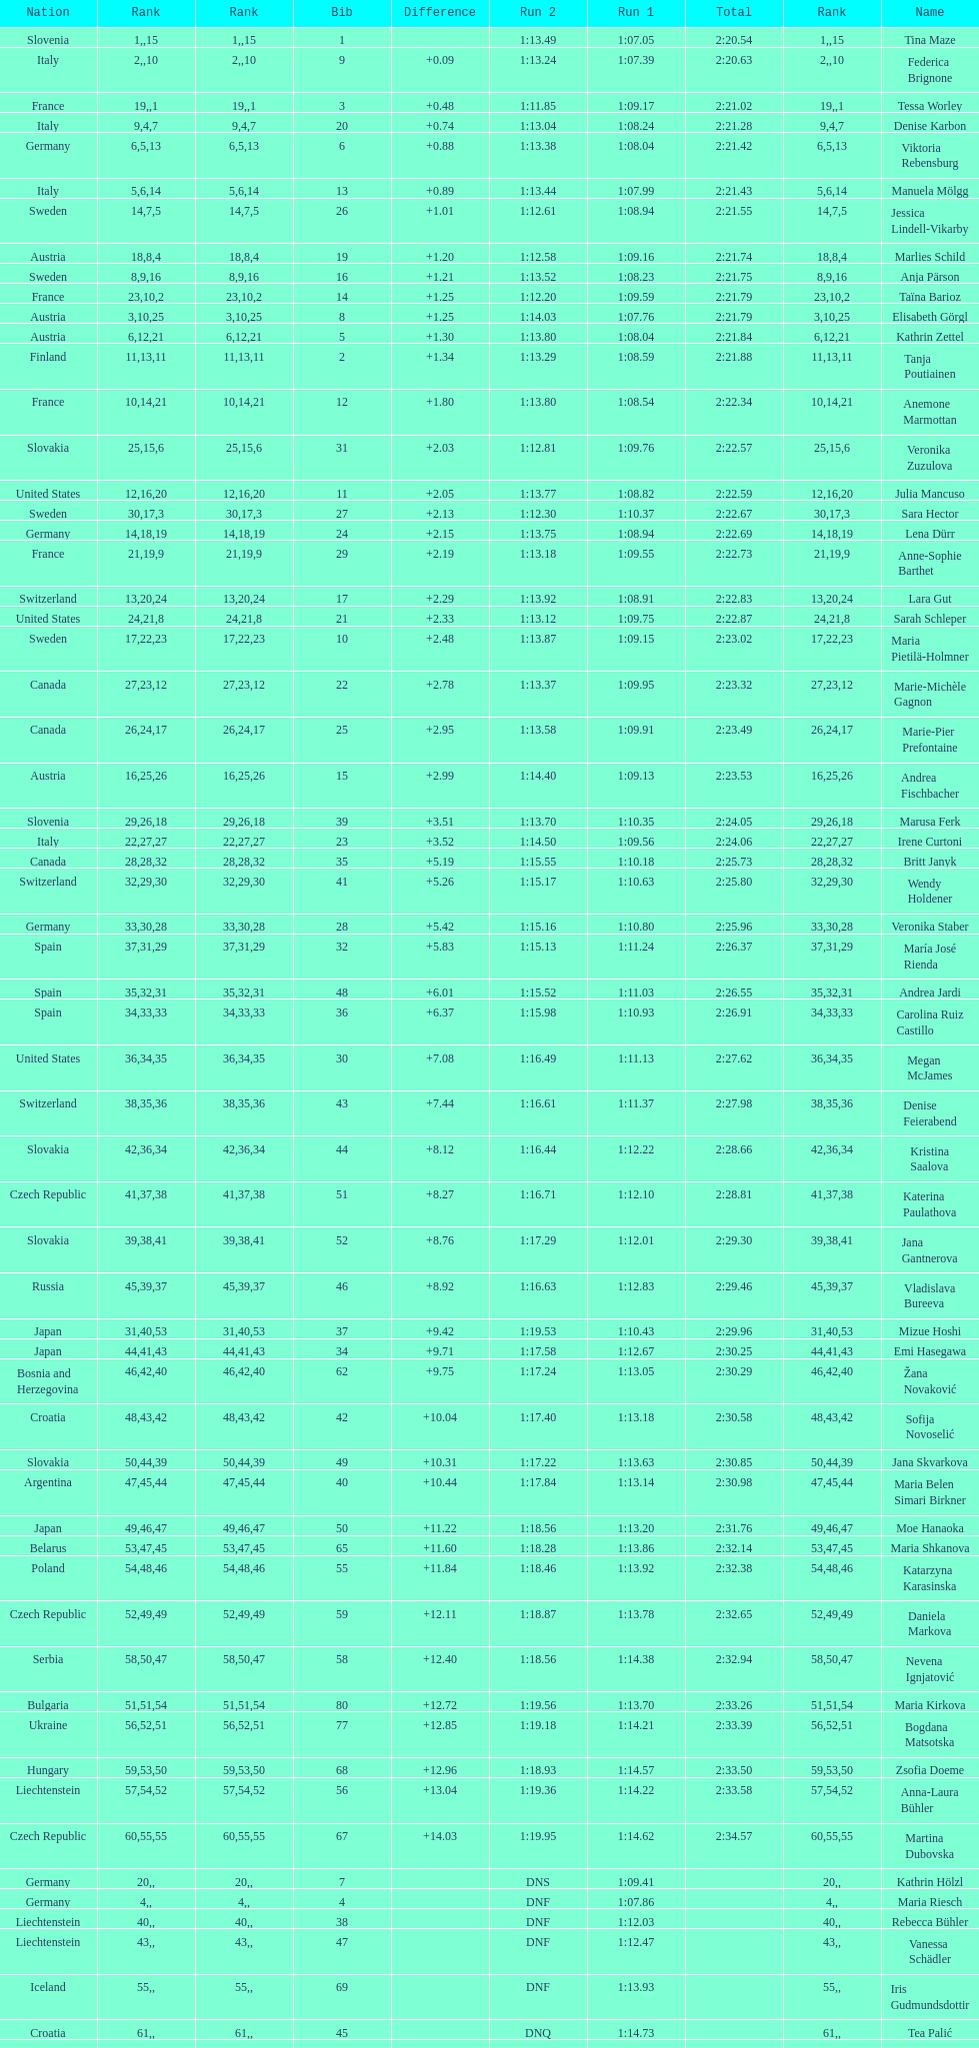How many athletes had the same position for both run 1 and run 2? 1. 